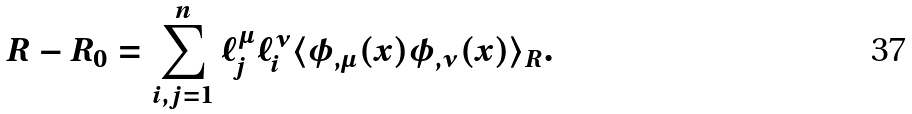Convert formula to latex. <formula><loc_0><loc_0><loc_500><loc_500>R - R _ { 0 } = \sum _ { i , j = 1 } ^ { n } { \ell _ { j } ^ { \mu } } { \ell _ { i } ^ { \nu } } \langle \phi _ { , \mu } ( x ) \phi _ { , \nu } ( x ) \rangle _ { R } .</formula> 